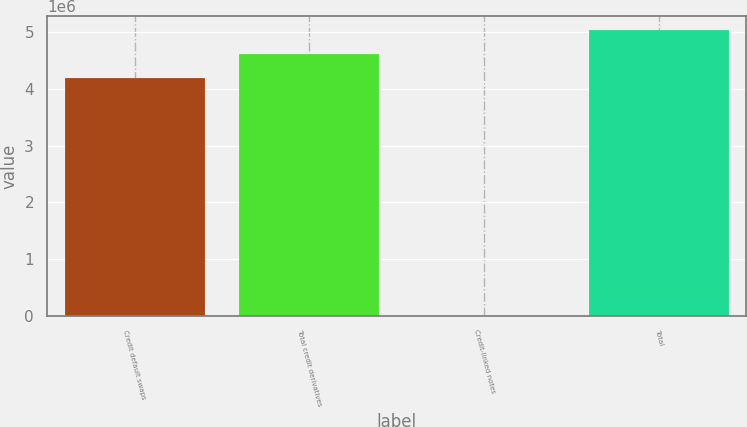Convert chart. <chart><loc_0><loc_0><loc_500><loc_500><bar_chart><fcel>Credit default swaps<fcel>Total credit derivatives<fcel>Credit-linked notes<fcel>Total<nl><fcel>4.19471e+06<fcel>4.61458e+06<fcel>1263<fcel>5.03445e+06<nl></chart> 